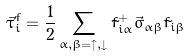<formula> <loc_0><loc_0><loc_500><loc_500>\vec { \tau } _ { i } ^ { f } = \frac { 1 } { 2 } \sum _ { \alpha , \beta = \uparrow , \downarrow } \tilde { f } _ { i \alpha } ^ { + } \vec { \sigma } _ { \alpha \beta } \tilde { f } _ { i \beta }</formula> 